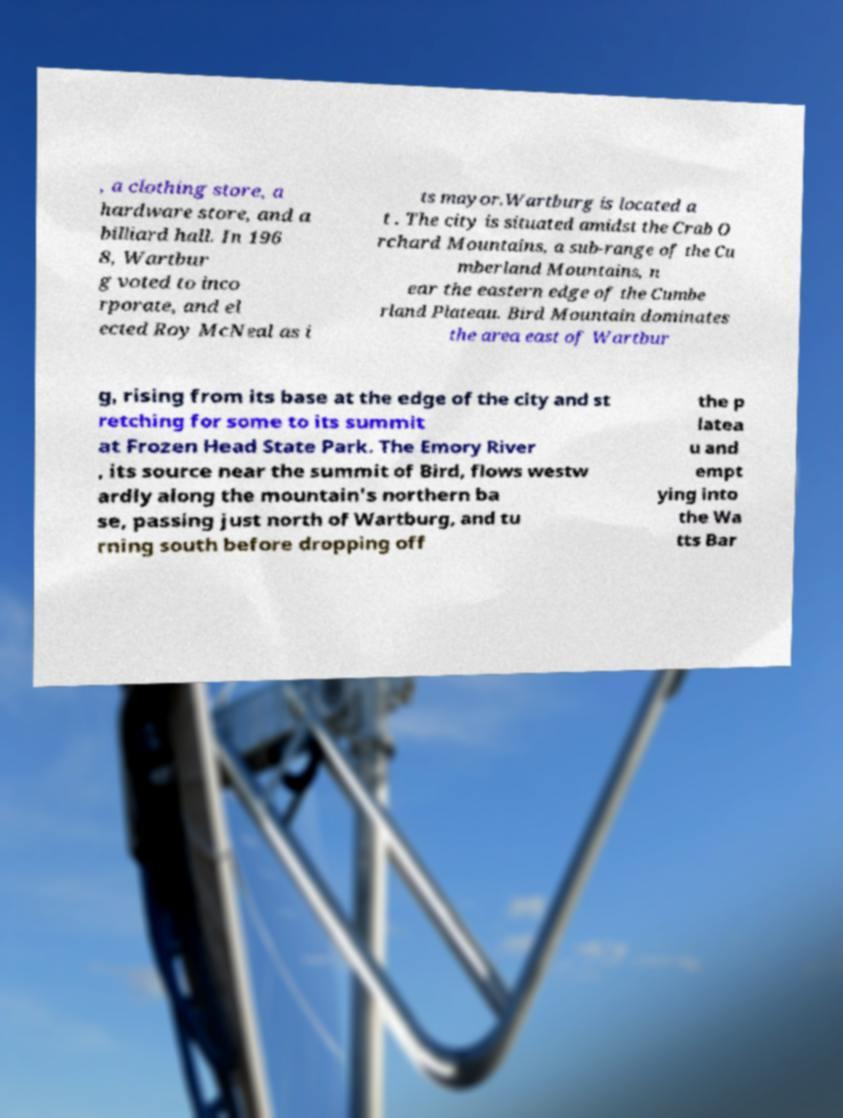I need the written content from this picture converted into text. Can you do that? , a clothing store, a hardware store, and a billiard hall. In 196 8, Wartbur g voted to inco rporate, and el ected Roy McNeal as i ts mayor.Wartburg is located a t . The city is situated amidst the Crab O rchard Mountains, a sub-range of the Cu mberland Mountains, n ear the eastern edge of the Cumbe rland Plateau. Bird Mountain dominates the area east of Wartbur g, rising from its base at the edge of the city and st retching for some to its summit at Frozen Head State Park. The Emory River , its source near the summit of Bird, flows westw ardly along the mountain's northern ba se, passing just north of Wartburg, and tu rning south before dropping off the p latea u and empt ying into the Wa tts Bar 